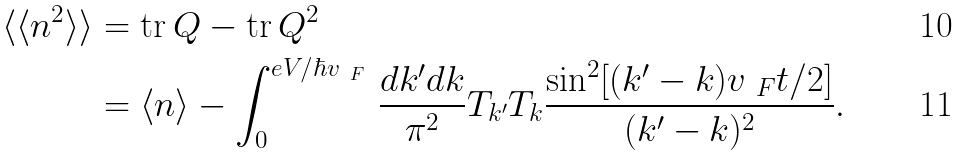Convert formula to latex. <formula><loc_0><loc_0><loc_500><loc_500>\langle \langle n ^ { 2 } \rangle \rangle & = \text {tr} \, Q - \text {tr} \, Q ^ { 2 } \\ & = \langle n \rangle - \int _ { 0 } ^ { e V / \hbar { v } _ { \ F } } \, \frac { d k ^ { \prime } d k } { \pi ^ { 2 } } T _ { k ^ { \prime } } T _ { k } \frac { \sin ^ { 2 } [ ( k ^ { \prime } - k ) v _ { \ F } t / 2 ] } { ( k ^ { \prime } - k ) ^ { 2 } } .</formula> 